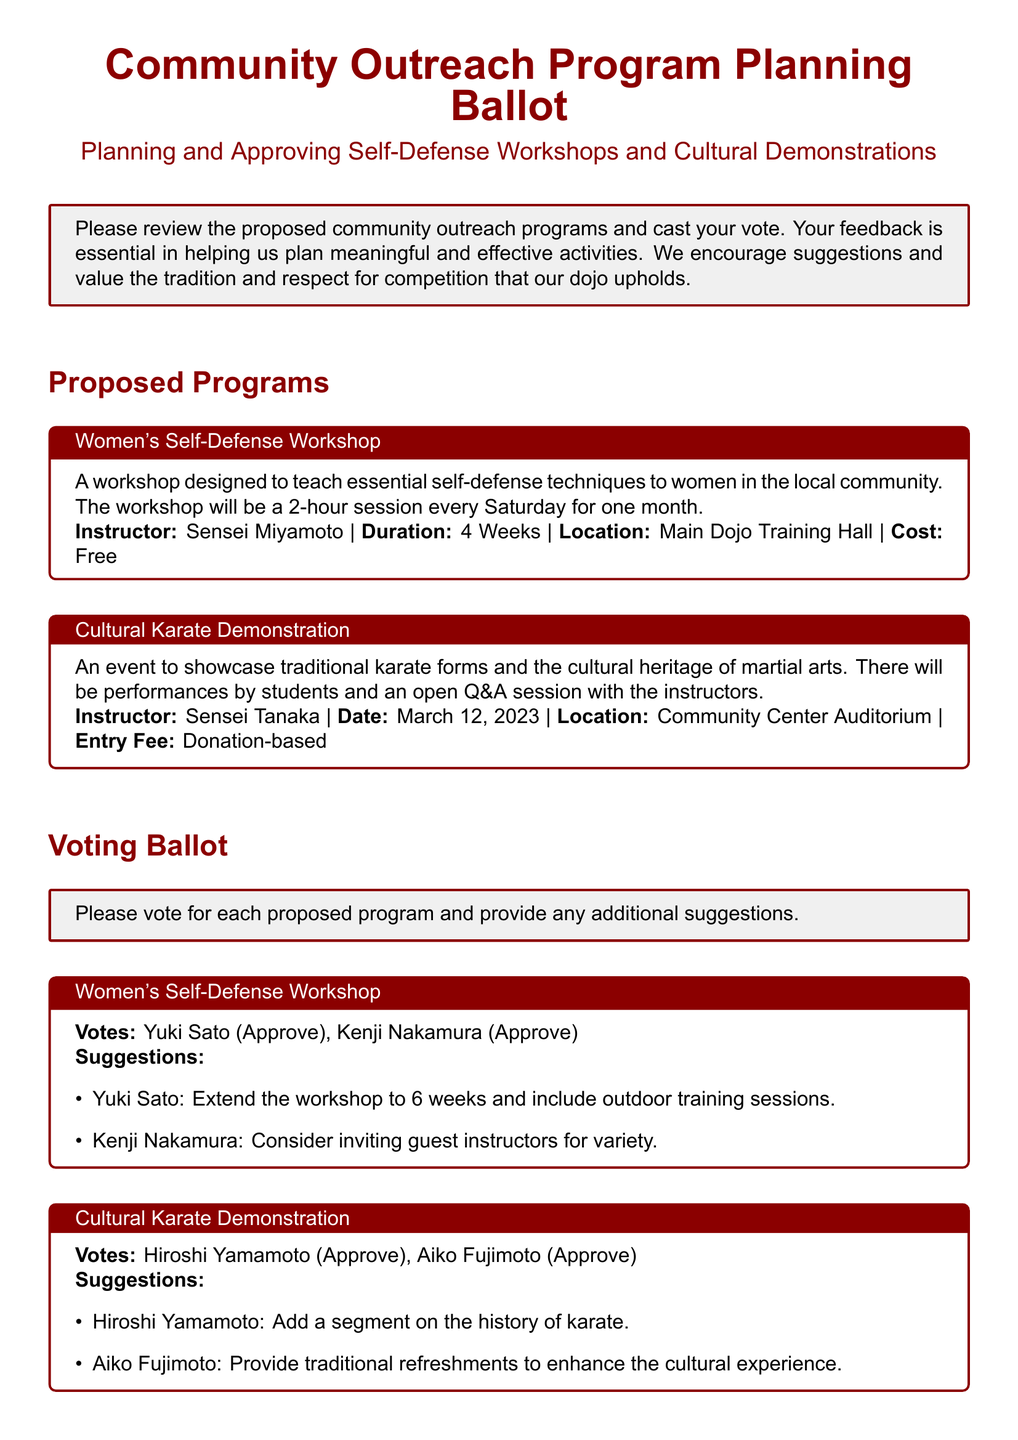What is the duration of the Women's Self-Defense Workshop? The duration of the workshop is specified as 4 weeks in the document.
Answer: 4 weeks Who is the instructor for the Cultural Karate Demonstration? The document states that Sensei Tanaka is the instructor for the Cultural Karate Demonstration.
Answer: Sensei Tanaka What additional suggestion did Yuki Sato make for the Women's Self-Defense Workshop? The document mentions Yuki Sato's suggestion to extend the workshop to 6 weeks and include outdoor training sessions.
Answer: Extend the workshop to 6 weeks and include outdoor training sessions How many members voted to approve the Cultural Karate Demonstration? The document shows that two members, Hiroshi Yamamoto and Aiko Fujimoto, voted to approve the Cultural Karate Demonstration.
Answer: 2 What is the entry fee for the Cultural Karate Demonstration? The entry fee for the event is stated as donation-based in the document.
Answer: Donation-based What is one suggestion made by Daisuke Matsui? Daisuke Matsui suggested implementing monthly community fitness runs in the document.
Answer: Implement monthly community fitness runs When is the date of the Cultural Karate Demonstration? The date is provided in the document as March 12, 2023.
Answer: March 12, 2023 What is the primary purpose of the community outreach programs? The document indicates that the primary purpose is to plan and approve meaningful and effective activities for the community.
Answer: Plan and approve meaningful and effective activities 